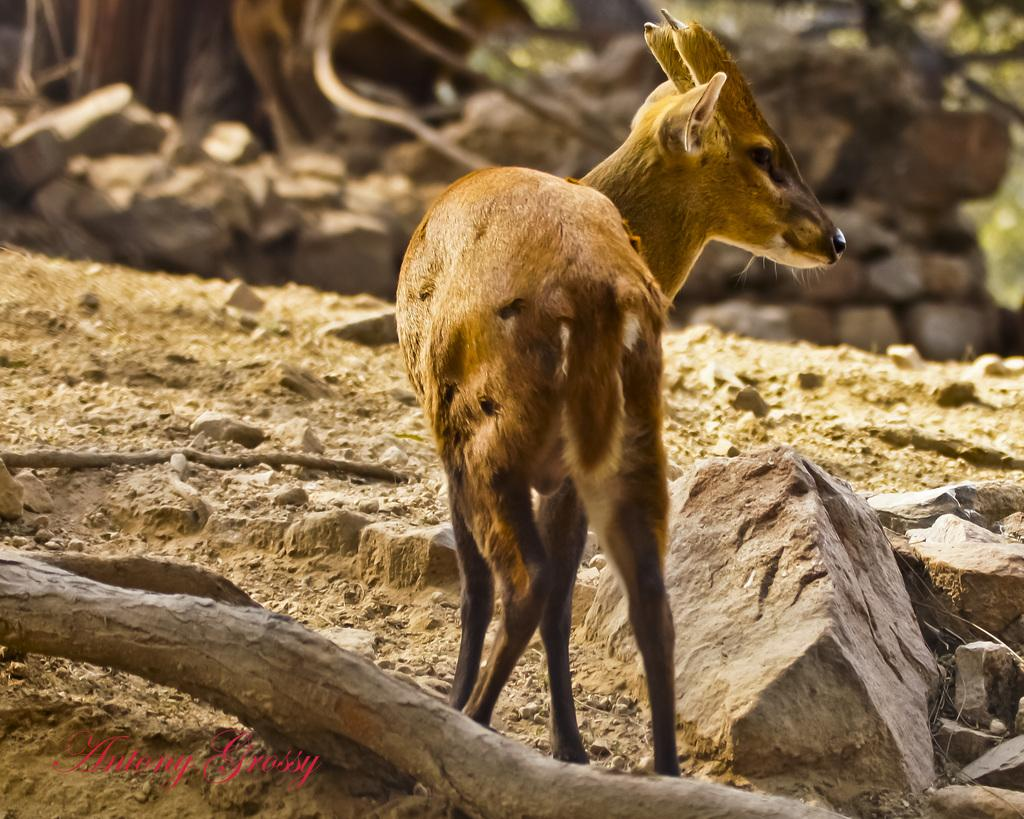What type of objects are in the foreground area of the image? There are stones and an animal in the foreground area of the image. Can you describe the animal in the foreground area of the image? There is an animal in the foreground area of the image, but its specific characteristics are not mentioned in the facts. What else is present in the foreground area of the image? There is a trunk in the foreground area of the image. What type of pan can be seen in the image? There is no pan present in the image. Is the cemetery visible in the image? There is no mention of a cemetery in the provided facts, so it cannot be determined if it is visible in the image. What type of joke is being played in the image? There is no joke being played in the image; it features stones, an animal, and a trunk in the foreground area. 